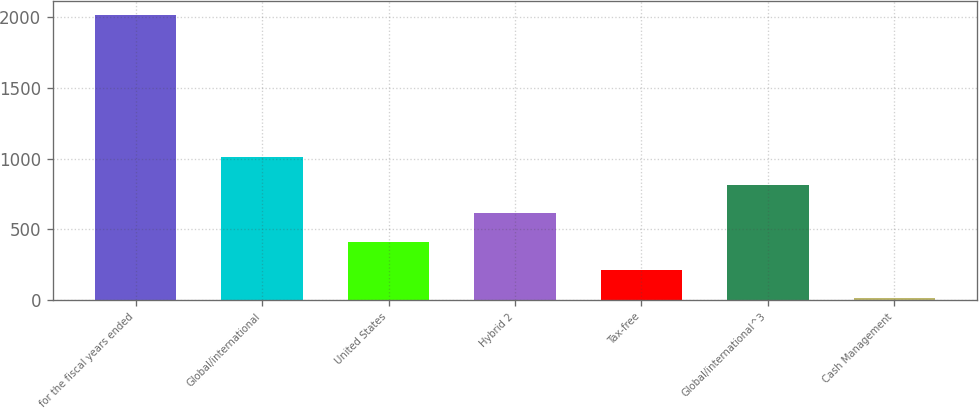<chart> <loc_0><loc_0><loc_500><loc_500><bar_chart><fcel>for the fiscal years ended<fcel>Global/international<fcel>United States<fcel>Hybrid 2<fcel>Tax-free<fcel>Global/international^3<fcel>Cash Management<nl><fcel>2014<fcel>1012.5<fcel>411.6<fcel>611.9<fcel>211.3<fcel>812.2<fcel>11<nl></chart> 